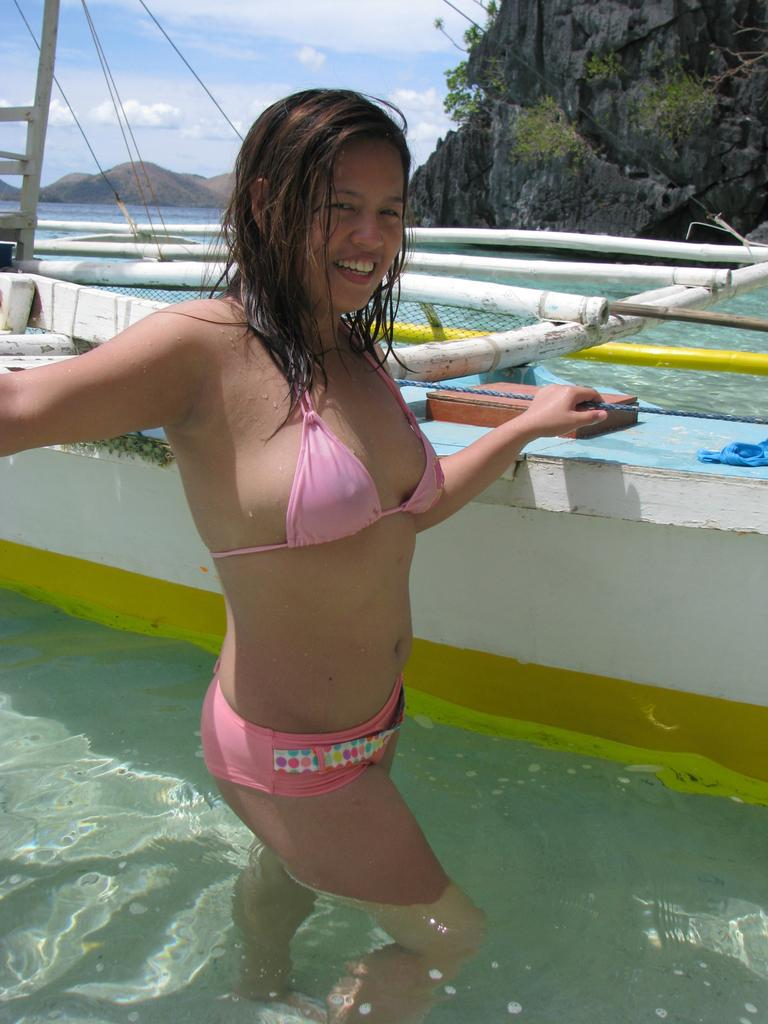What is the woman in the foreground of the image doing? The woman is in the water in the foreground of the image. What else can be seen in the image besides the woman in the water? There is a boat and mountains in the background of the image. What is visible in the sky in the background of the image? The sky is visible in the background of the image, and there are clouds in the sky. How many toes can be seen on the woman's sheet in the image? There is no sheet or toes visible in the image; it features a woman in the water and a boat in the background. 